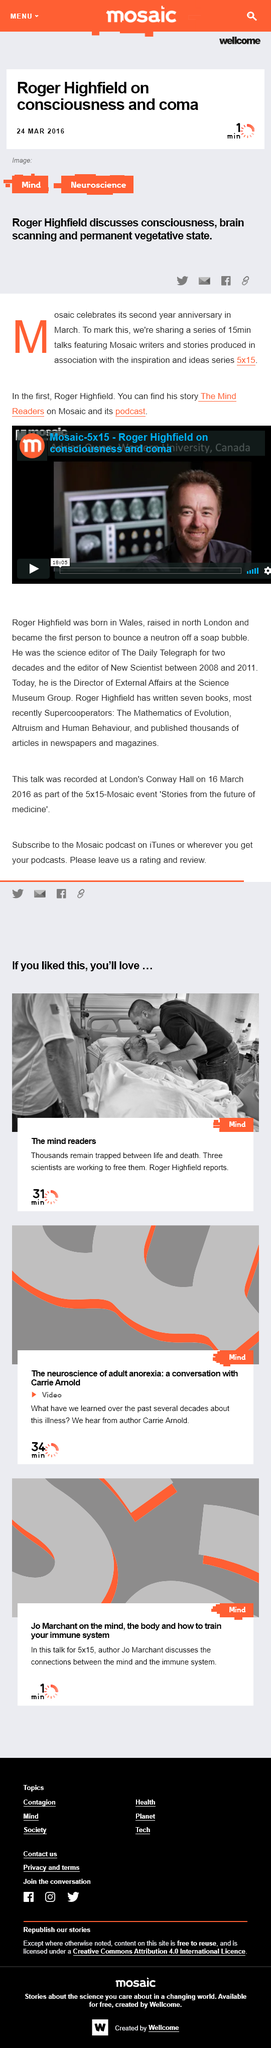Give some essential details in this illustration. The first person to bounce a neutron off a soap bubble was Roger Highfield. Roger Highfield, who was born in Wales, was born in Wales. The video discussing consciousness and coma was made by Roger Highfield. 